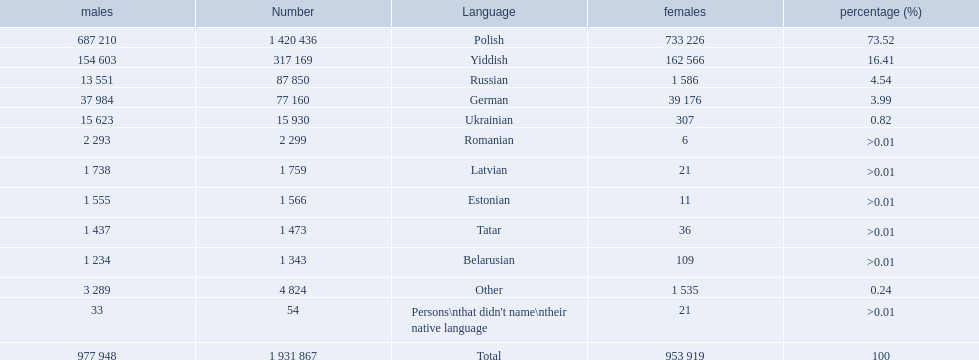Which languages are spoken by more than 50,000 people? Polish, Yiddish, Russian, German. Of these languages, which ones are spoken by less than 15% of the population? Russian, German. Of the remaining two, which one is spoken by 37,984 males? German. 